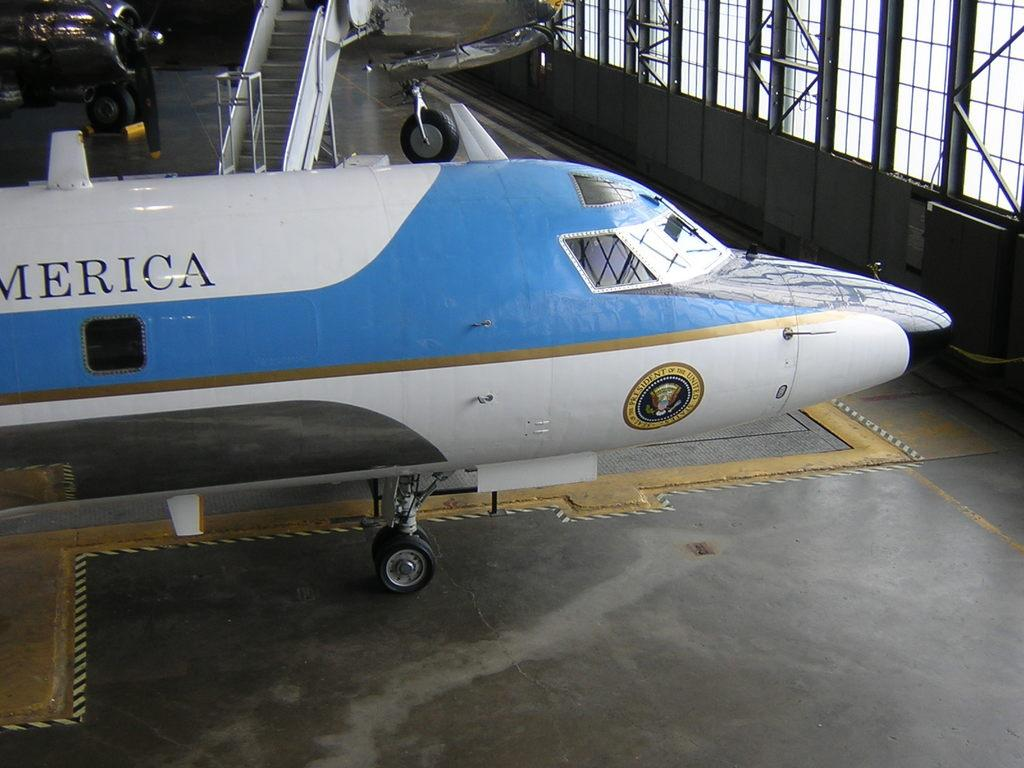Provide a one-sentence caption for the provided image. a plane that has a president logo on the bottom of it. 